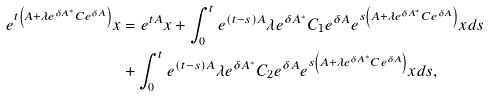Convert formula to latex. <formula><loc_0><loc_0><loc_500><loc_500>e ^ { t \left ( A + \lambda e ^ { \delta A ^ { \ast } } C e ^ { \delta A } \right ) } x & = e ^ { t A } x + \int _ { 0 } ^ { t } e ^ { \left ( t - s \right ) A } \lambda e ^ { \delta A ^ { \ast } } C _ { 1 } e ^ { \delta A } e ^ { s \left ( A + \lambda e ^ { \delta A ^ { \ast } } C e ^ { \delta A } \right ) } x d s \\ & + \int _ { 0 } ^ { t } e ^ { \left ( t - s \right ) A } \lambda e ^ { \delta A ^ { \ast } } C _ { 2 } e ^ { \delta A } e ^ { s \left ( A + \lambda e ^ { \delta A ^ { \ast } } C e ^ { \delta A } \right ) } x d s ,</formula> 